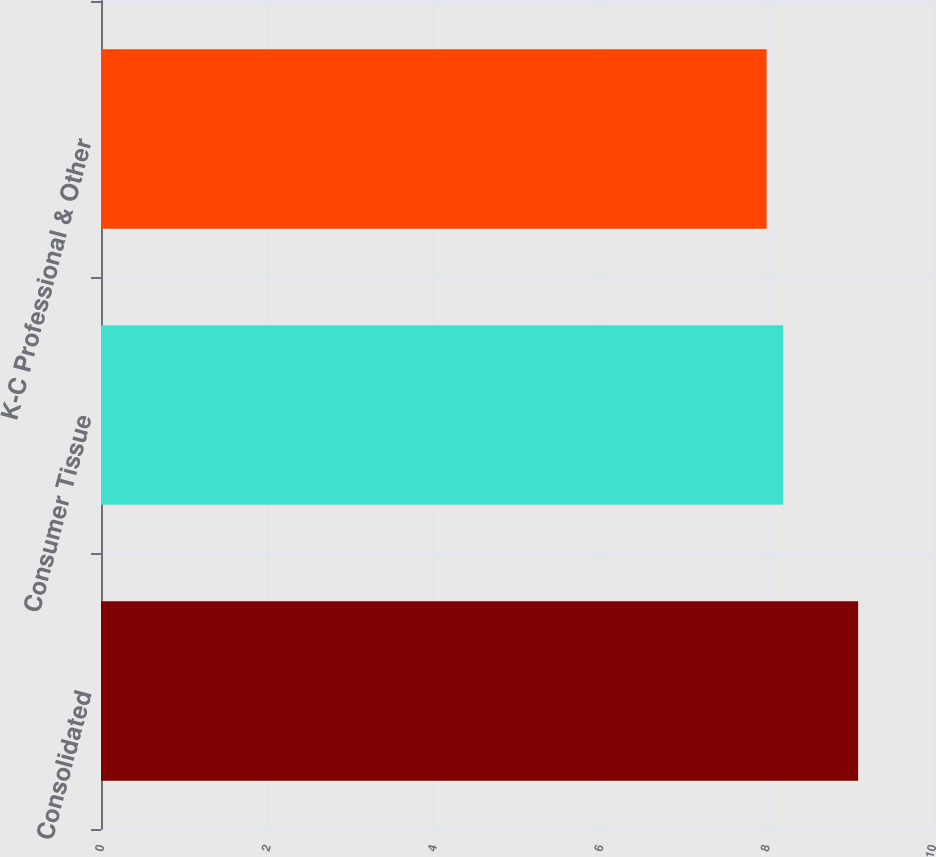<chart> <loc_0><loc_0><loc_500><loc_500><bar_chart><fcel>Consolidated<fcel>Consumer Tissue<fcel>K-C Professional & Other<nl><fcel>9.1<fcel>8.2<fcel>8<nl></chart> 